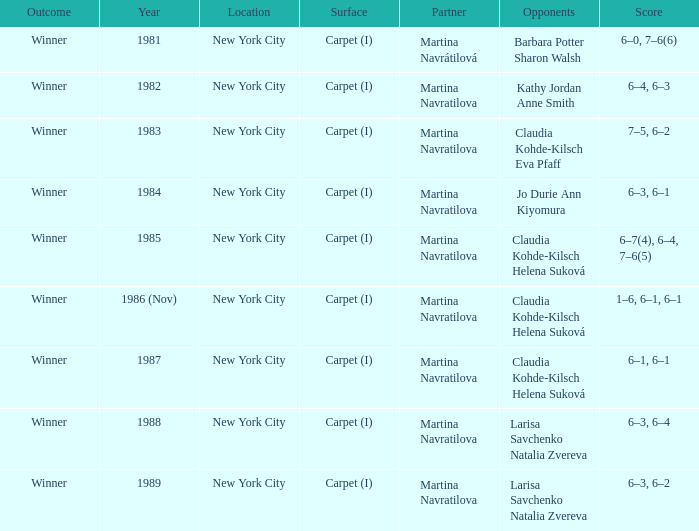Can you give me this table as a dict? {'header': ['Outcome', 'Year', 'Location', 'Surface', 'Partner', 'Opponents', 'Score'], 'rows': [['Winner', '1981', 'New York City', 'Carpet (I)', 'Martina Navrátilová', 'Barbara Potter Sharon Walsh', '6–0, 7–6(6)'], ['Winner', '1982', 'New York City', 'Carpet (I)', 'Martina Navratilova', 'Kathy Jordan Anne Smith', '6–4, 6–3'], ['Winner', '1983', 'New York City', 'Carpet (I)', 'Martina Navratilova', 'Claudia Kohde-Kilsch Eva Pfaff', '7–5, 6–2'], ['Winner', '1984', 'New York City', 'Carpet (I)', 'Martina Navratilova', 'Jo Durie Ann Kiyomura', '6–3, 6–1'], ['Winner', '1985', 'New York City', 'Carpet (I)', 'Martina Navratilova', 'Claudia Kohde-Kilsch Helena Suková', '6–7(4), 6–4, 7–6(5)'], ['Winner', '1986 (Nov)', 'New York City', 'Carpet (I)', 'Martina Navratilova', 'Claudia Kohde-Kilsch Helena Suková', '1–6, 6–1, 6–1'], ['Winner', '1987', 'New York City', 'Carpet (I)', 'Martina Navratilova', 'Claudia Kohde-Kilsch Helena Suková', '6–1, 6–1'], ['Winner', '1988', 'New York City', 'Carpet (I)', 'Martina Navratilova', 'Larisa Savchenko Natalia Zvereva', '6–3, 6–4'], ['Winner', '1989', 'New York City', 'Carpet (I)', 'Martina Navratilova', 'Larisa Savchenko Natalia Zvereva', '6–3, 6–2']]} How many locations hosted Claudia Kohde-Kilsch Eva Pfaff? 1.0. 